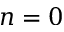<formula> <loc_0><loc_0><loc_500><loc_500>n = 0</formula> 